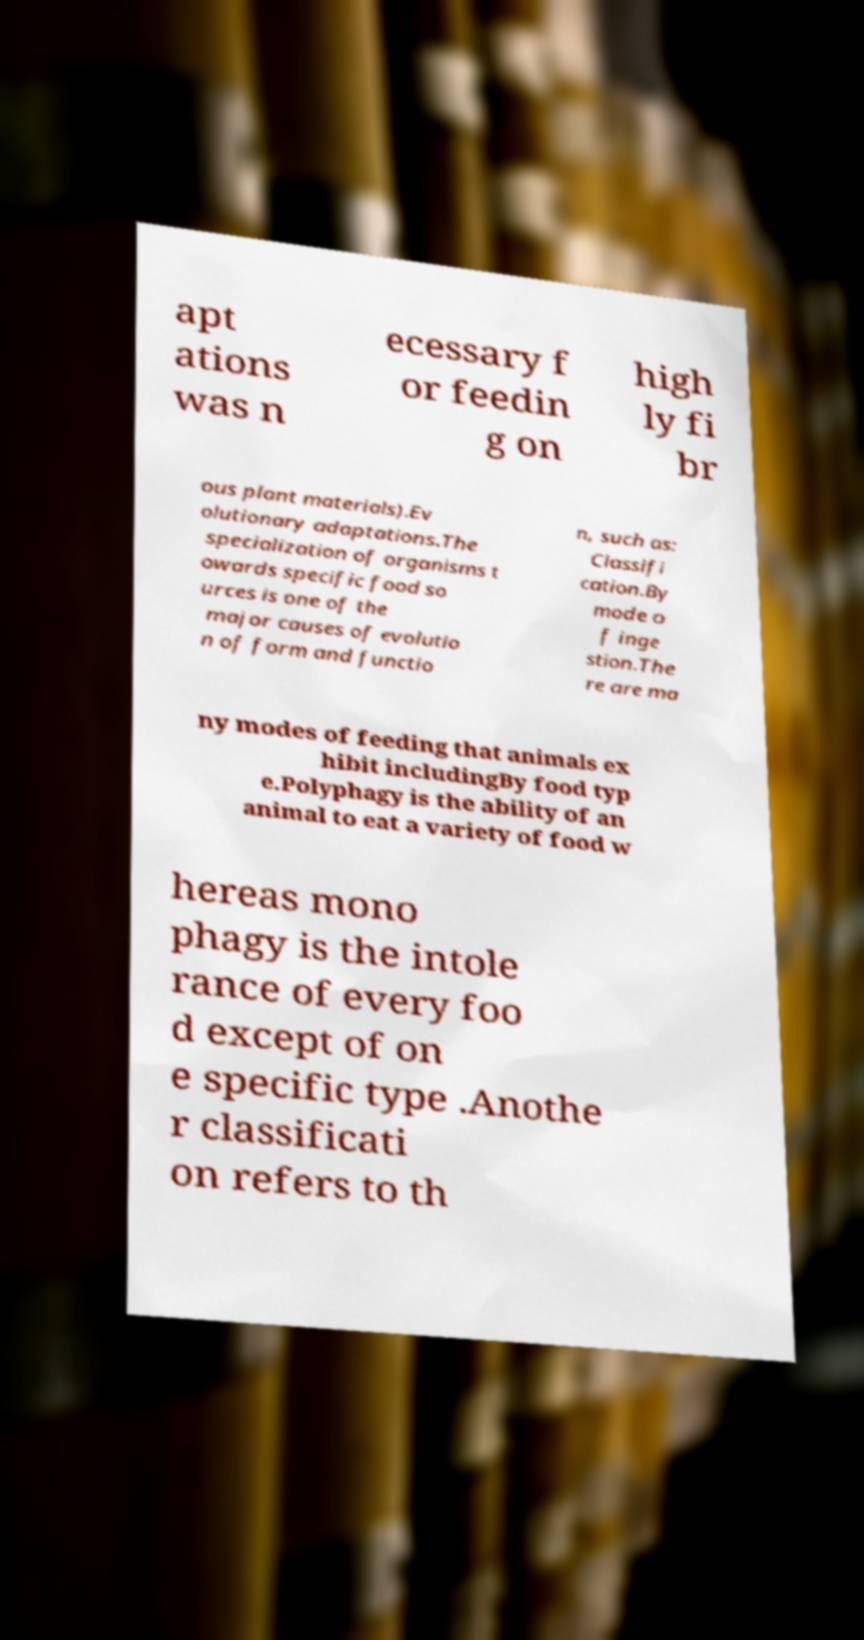What messages or text are displayed in this image? I need them in a readable, typed format. apt ations was n ecessary f or feedin g on high ly fi br ous plant materials).Ev olutionary adaptations.The specialization of organisms t owards specific food so urces is one of the major causes of evolutio n of form and functio n, such as: Classifi cation.By mode o f inge stion.The re are ma ny modes of feeding that animals ex hibit includingBy food typ e.Polyphagy is the ability of an animal to eat a variety of food w hereas mono phagy is the intole rance of every foo d except of on e specific type .Anothe r classificati on refers to th 